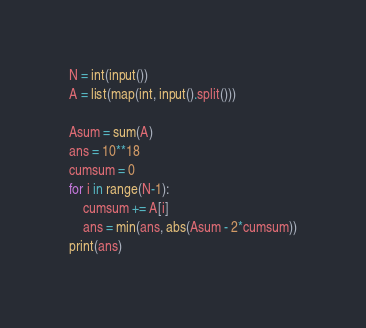Convert code to text. <code><loc_0><loc_0><loc_500><loc_500><_Python_>N = int(input())
A = list(map(int, input().split()))

Asum = sum(A)
ans = 10**18
cumsum = 0
for i in range(N-1):
    cumsum += A[i]
    ans = min(ans, abs(Asum - 2*cumsum))
print(ans)</code> 